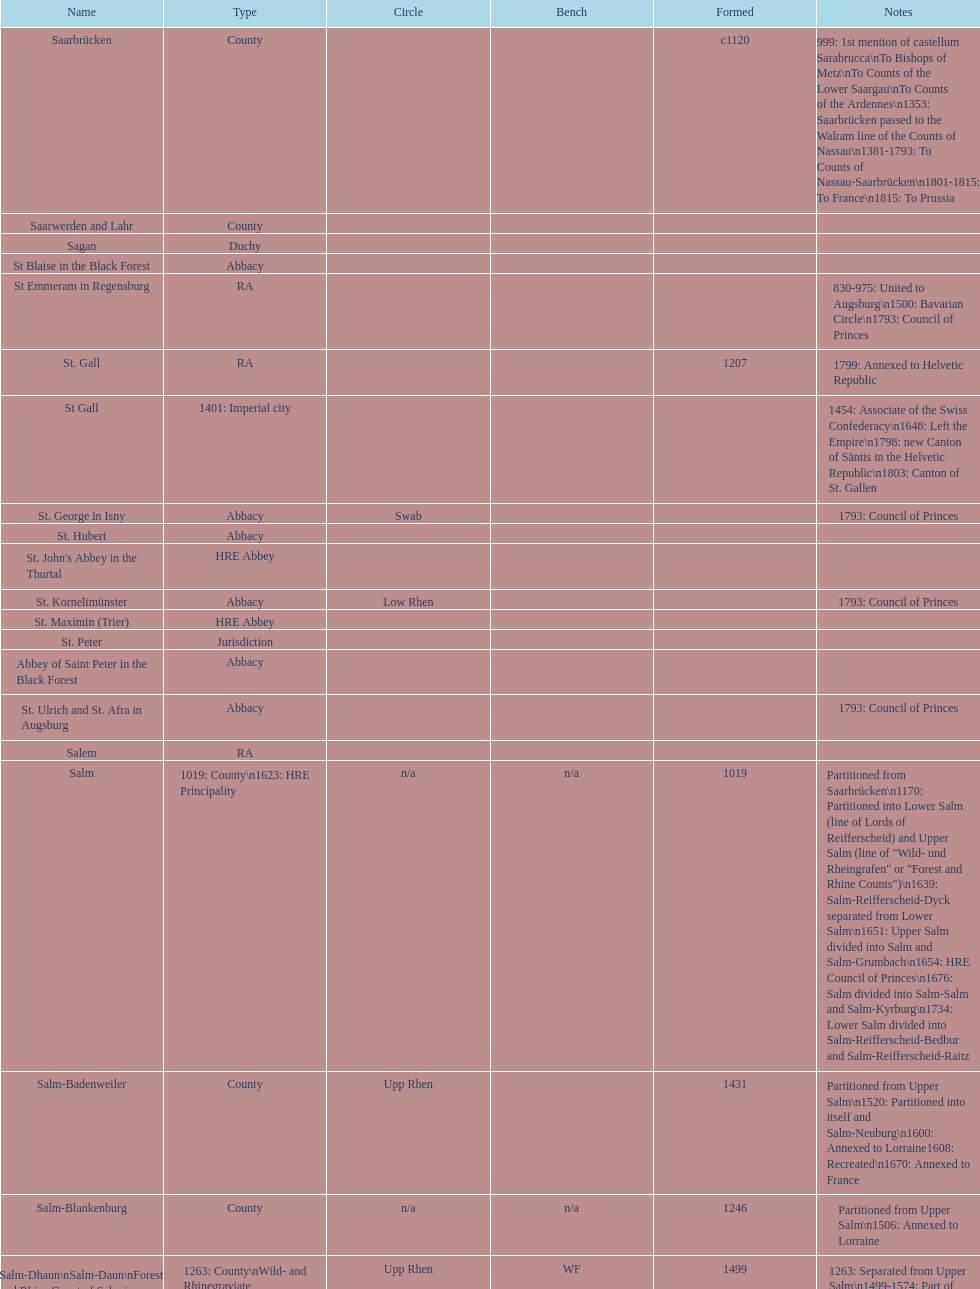What is the state above "sagan"? Saarwerden and Lahr. 